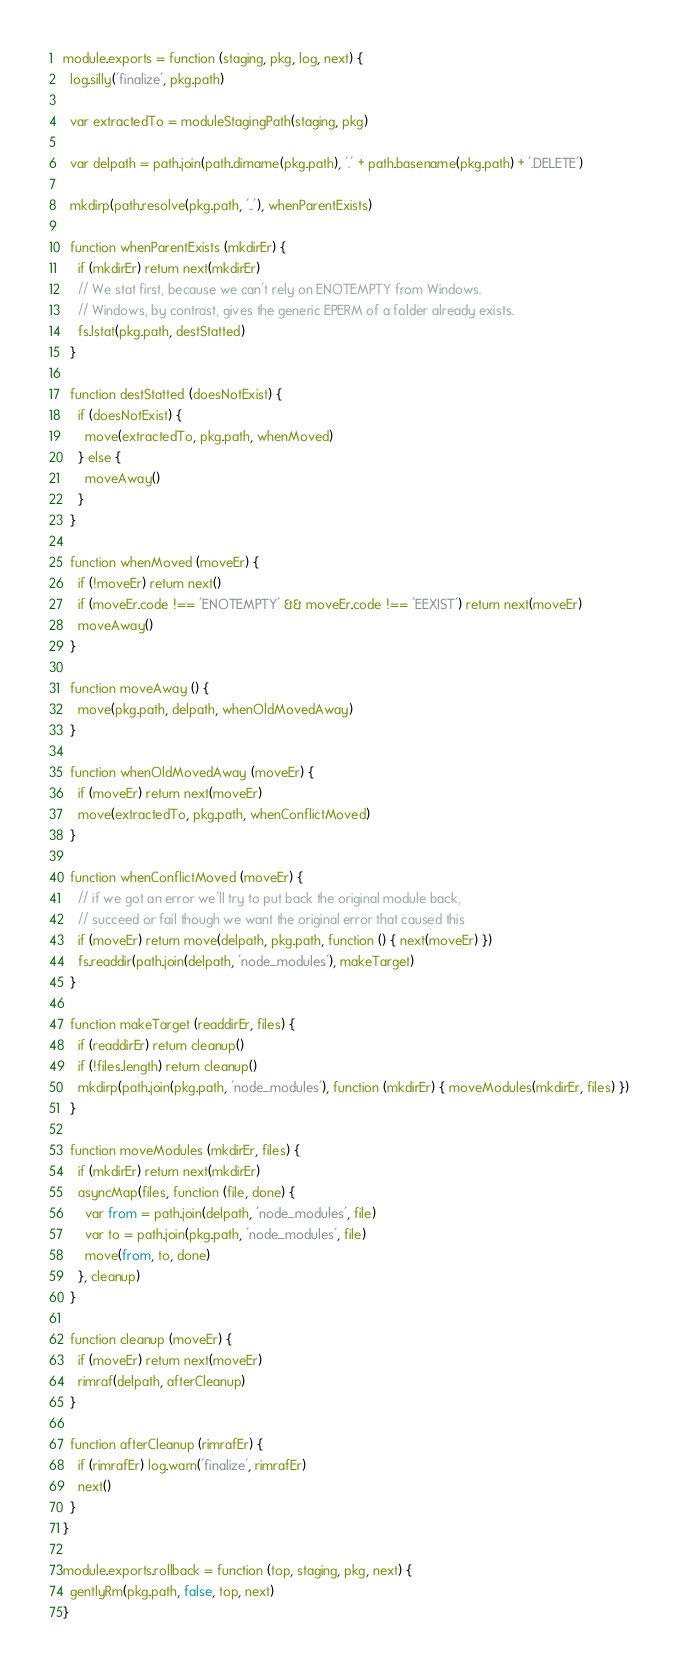<code> <loc_0><loc_0><loc_500><loc_500><_JavaScript_>
module.exports = function (staging, pkg, log, next) {
  log.silly('finalize', pkg.path)

  var extractedTo = moduleStagingPath(staging, pkg)

  var delpath = path.join(path.dirname(pkg.path), '.' + path.basename(pkg.path) + '.DELETE')

  mkdirp(path.resolve(pkg.path, '..'), whenParentExists)

  function whenParentExists (mkdirEr) {
    if (mkdirEr) return next(mkdirEr)
    // We stat first, because we can't rely on ENOTEMPTY from Windows.
    // Windows, by contrast, gives the generic EPERM of a folder already exists.
    fs.lstat(pkg.path, destStatted)
  }

  function destStatted (doesNotExist) {
    if (doesNotExist) {
      move(extractedTo, pkg.path, whenMoved)
    } else {
      moveAway()
    }
  }

  function whenMoved (moveEr) {
    if (!moveEr) return next()
    if (moveEr.code !== 'ENOTEMPTY' && moveEr.code !== 'EEXIST') return next(moveEr)
    moveAway()
  }

  function moveAway () {
    move(pkg.path, delpath, whenOldMovedAway)
  }

  function whenOldMovedAway (moveEr) {
    if (moveEr) return next(moveEr)
    move(extractedTo, pkg.path, whenConflictMoved)
  }

  function whenConflictMoved (moveEr) {
    // if we got an error we'll try to put back the original module back,
    // succeed or fail though we want the original error that caused this
    if (moveEr) return move(delpath, pkg.path, function () { next(moveEr) })
    fs.readdir(path.join(delpath, 'node_modules'), makeTarget)
  }

  function makeTarget (readdirEr, files) {
    if (readdirEr) return cleanup()
    if (!files.length) return cleanup()
    mkdirp(path.join(pkg.path, 'node_modules'), function (mkdirEr) { moveModules(mkdirEr, files) })
  }

  function moveModules (mkdirEr, files) {
    if (mkdirEr) return next(mkdirEr)
    asyncMap(files, function (file, done) {
      var from = path.join(delpath, 'node_modules', file)
      var to = path.join(pkg.path, 'node_modules', file)
      move(from, to, done)
    }, cleanup)
  }

  function cleanup (moveEr) {
    if (moveEr) return next(moveEr)
    rimraf(delpath, afterCleanup)
  }

  function afterCleanup (rimrafEr) {
    if (rimrafEr) log.warn('finalize', rimrafEr)
    next()
  }
}

module.exports.rollback = function (top, staging, pkg, next) {
  gentlyRm(pkg.path, false, top, next)
}
</code> 